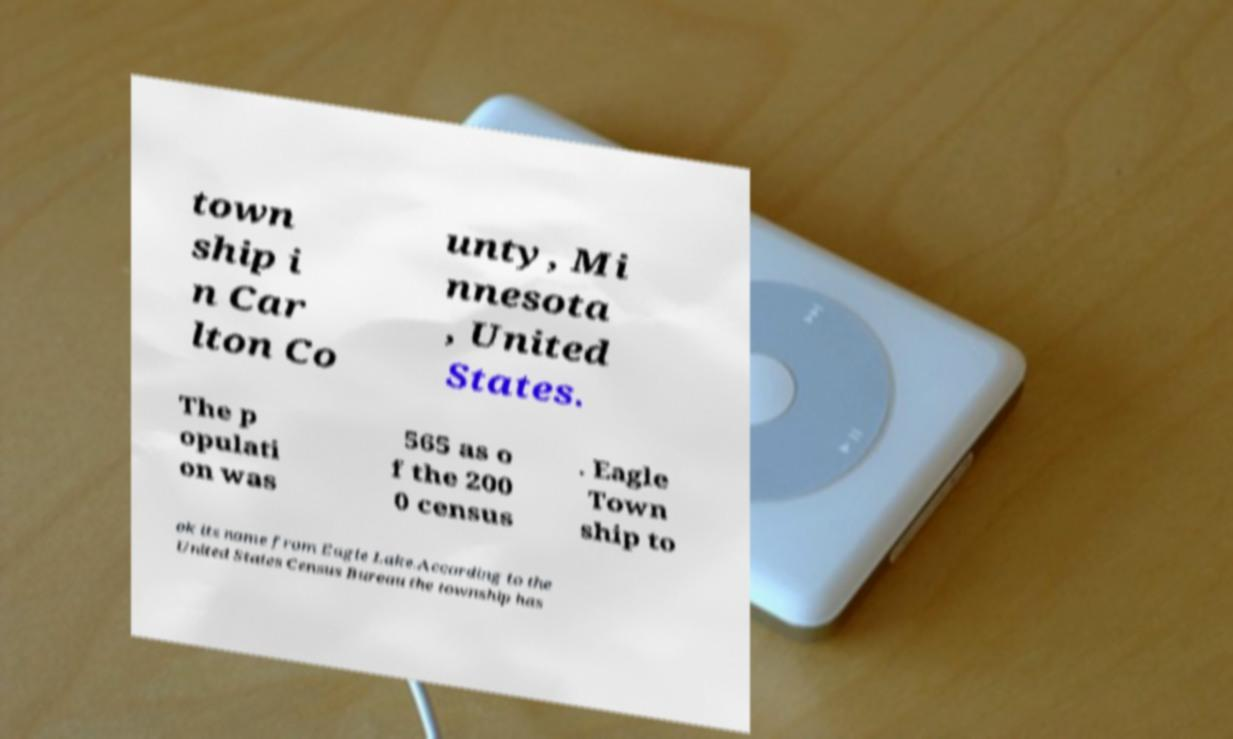Please identify and transcribe the text found in this image. town ship i n Car lton Co unty, Mi nnesota , United States. The p opulati on was 565 as o f the 200 0 census . Eagle Town ship to ok its name from Eagle Lake.According to the United States Census Bureau the township has 